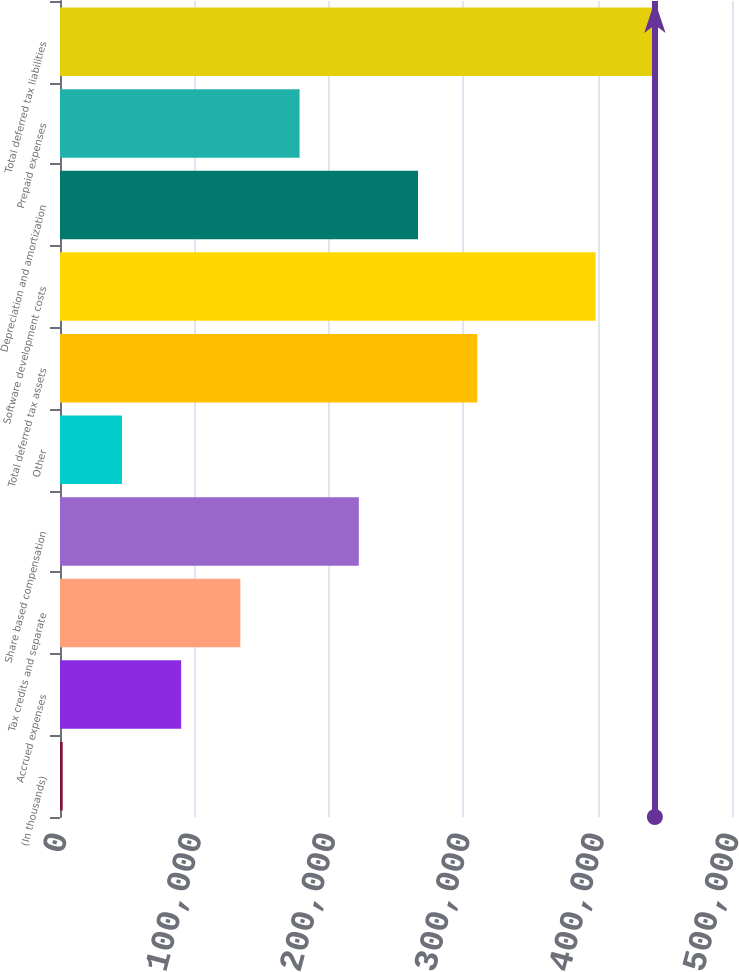<chart> <loc_0><loc_0><loc_500><loc_500><bar_chart><fcel>(In thousands)<fcel>Accrued expenses<fcel>Tax credits and separate<fcel>Share based compensation<fcel>Other<fcel>Total deferred tax assets<fcel>Software development costs<fcel>Depreciation and amortization<fcel>Prepaid expenses<fcel>Total deferred tax liabilities<nl><fcel>2016<fcel>90136.2<fcel>134196<fcel>222316<fcel>46076.1<fcel>310437<fcel>398557<fcel>266377<fcel>178256<fcel>442617<nl></chart> 